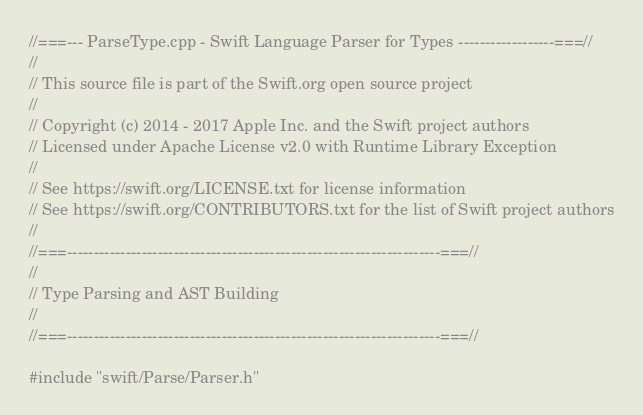Convert code to text. <code><loc_0><loc_0><loc_500><loc_500><_C++_>//===--- ParseType.cpp - Swift Language Parser for Types ------------------===//
//
// This source file is part of the Swift.org open source project
//
// Copyright (c) 2014 - 2017 Apple Inc. and the Swift project authors
// Licensed under Apache License v2.0 with Runtime Library Exception
//
// See https://swift.org/LICENSE.txt for license information
// See https://swift.org/CONTRIBUTORS.txt for the list of Swift project authors
//
//===----------------------------------------------------------------------===//
//
// Type Parsing and AST Building
//
//===----------------------------------------------------------------------===//

#include "swift/Parse/Parser.h"</code> 